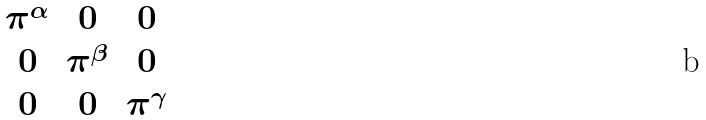Convert formula to latex. <formula><loc_0><loc_0><loc_500><loc_500>\begin{matrix} \pi ^ { \alpha } & 0 & 0 \\ 0 & \pi ^ { \beta } & 0 \\ 0 & 0 & \pi ^ { \gamma } \end{matrix}</formula> 